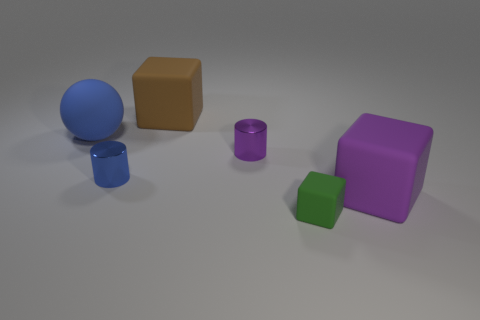What number of other things are there of the same shape as the blue metallic object?
Keep it short and to the point. 1. There is a shiny cylinder that is to the left of the large brown cube; does it have the same color as the sphere?
Provide a succinct answer. Yes. What number of other objects are the same size as the blue rubber sphere?
Give a very brief answer. 2. Does the blue cylinder have the same material as the green cube?
Offer a terse response. No. There is a tiny shiny cylinder that is to the right of the rubber block behind the blue cylinder; what is its color?
Offer a terse response. Purple. What is the size of the brown thing that is the same shape as the purple rubber thing?
Your response must be concise. Large. There is a big rubber object on the left side of the big cube that is behind the blue rubber thing; how many big rubber things are in front of it?
Offer a very short reply. 1. Is the number of purple things greater than the number of big purple cubes?
Offer a very short reply. Yes. How many big blue rubber objects are there?
Your answer should be compact. 1. There is a matte thing left of the large matte cube behind the metal cylinder that is on the left side of the brown cube; what shape is it?
Keep it short and to the point. Sphere. 